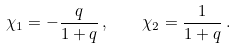<formula> <loc_0><loc_0><loc_500><loc_500>\chi _ { 1 } = - \frac { q } { 1 + q } \, , \quad \chi _ { 2 } = \frac { 1 } { 1 + q } \, .</formula> 